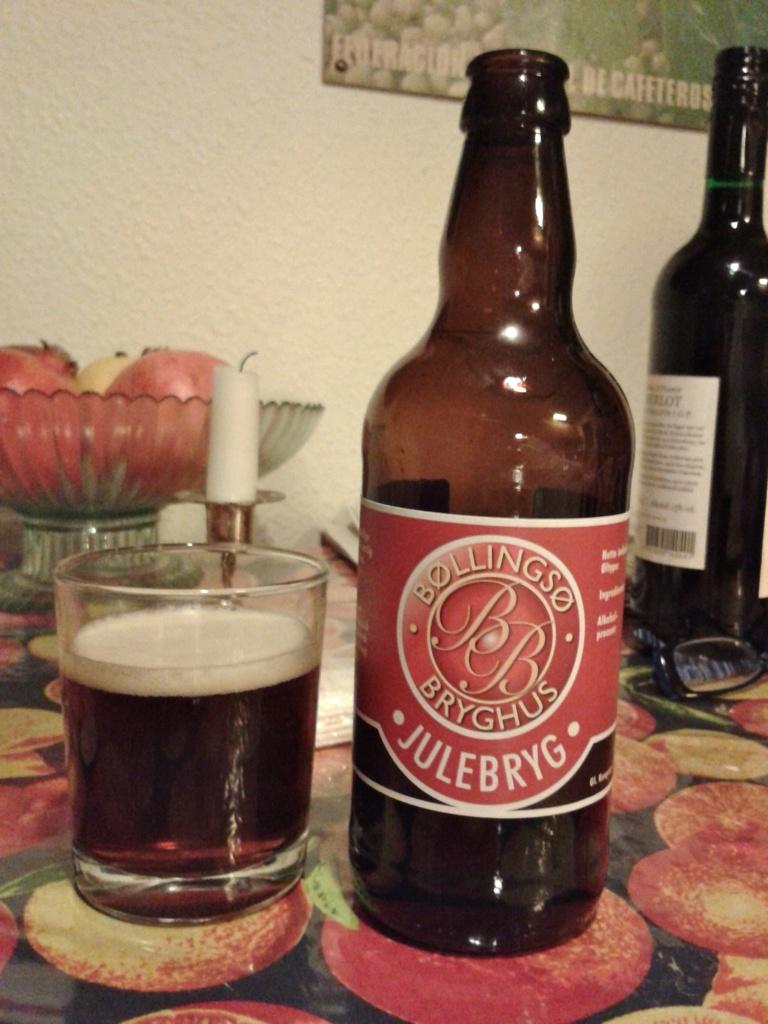What brand is on the bottom of the bottle label?
Your answer should be very brief. Julebryg. What do the initials "bb" stand for on the bottle?
Your response must be concise. Bollingso bryghus. 